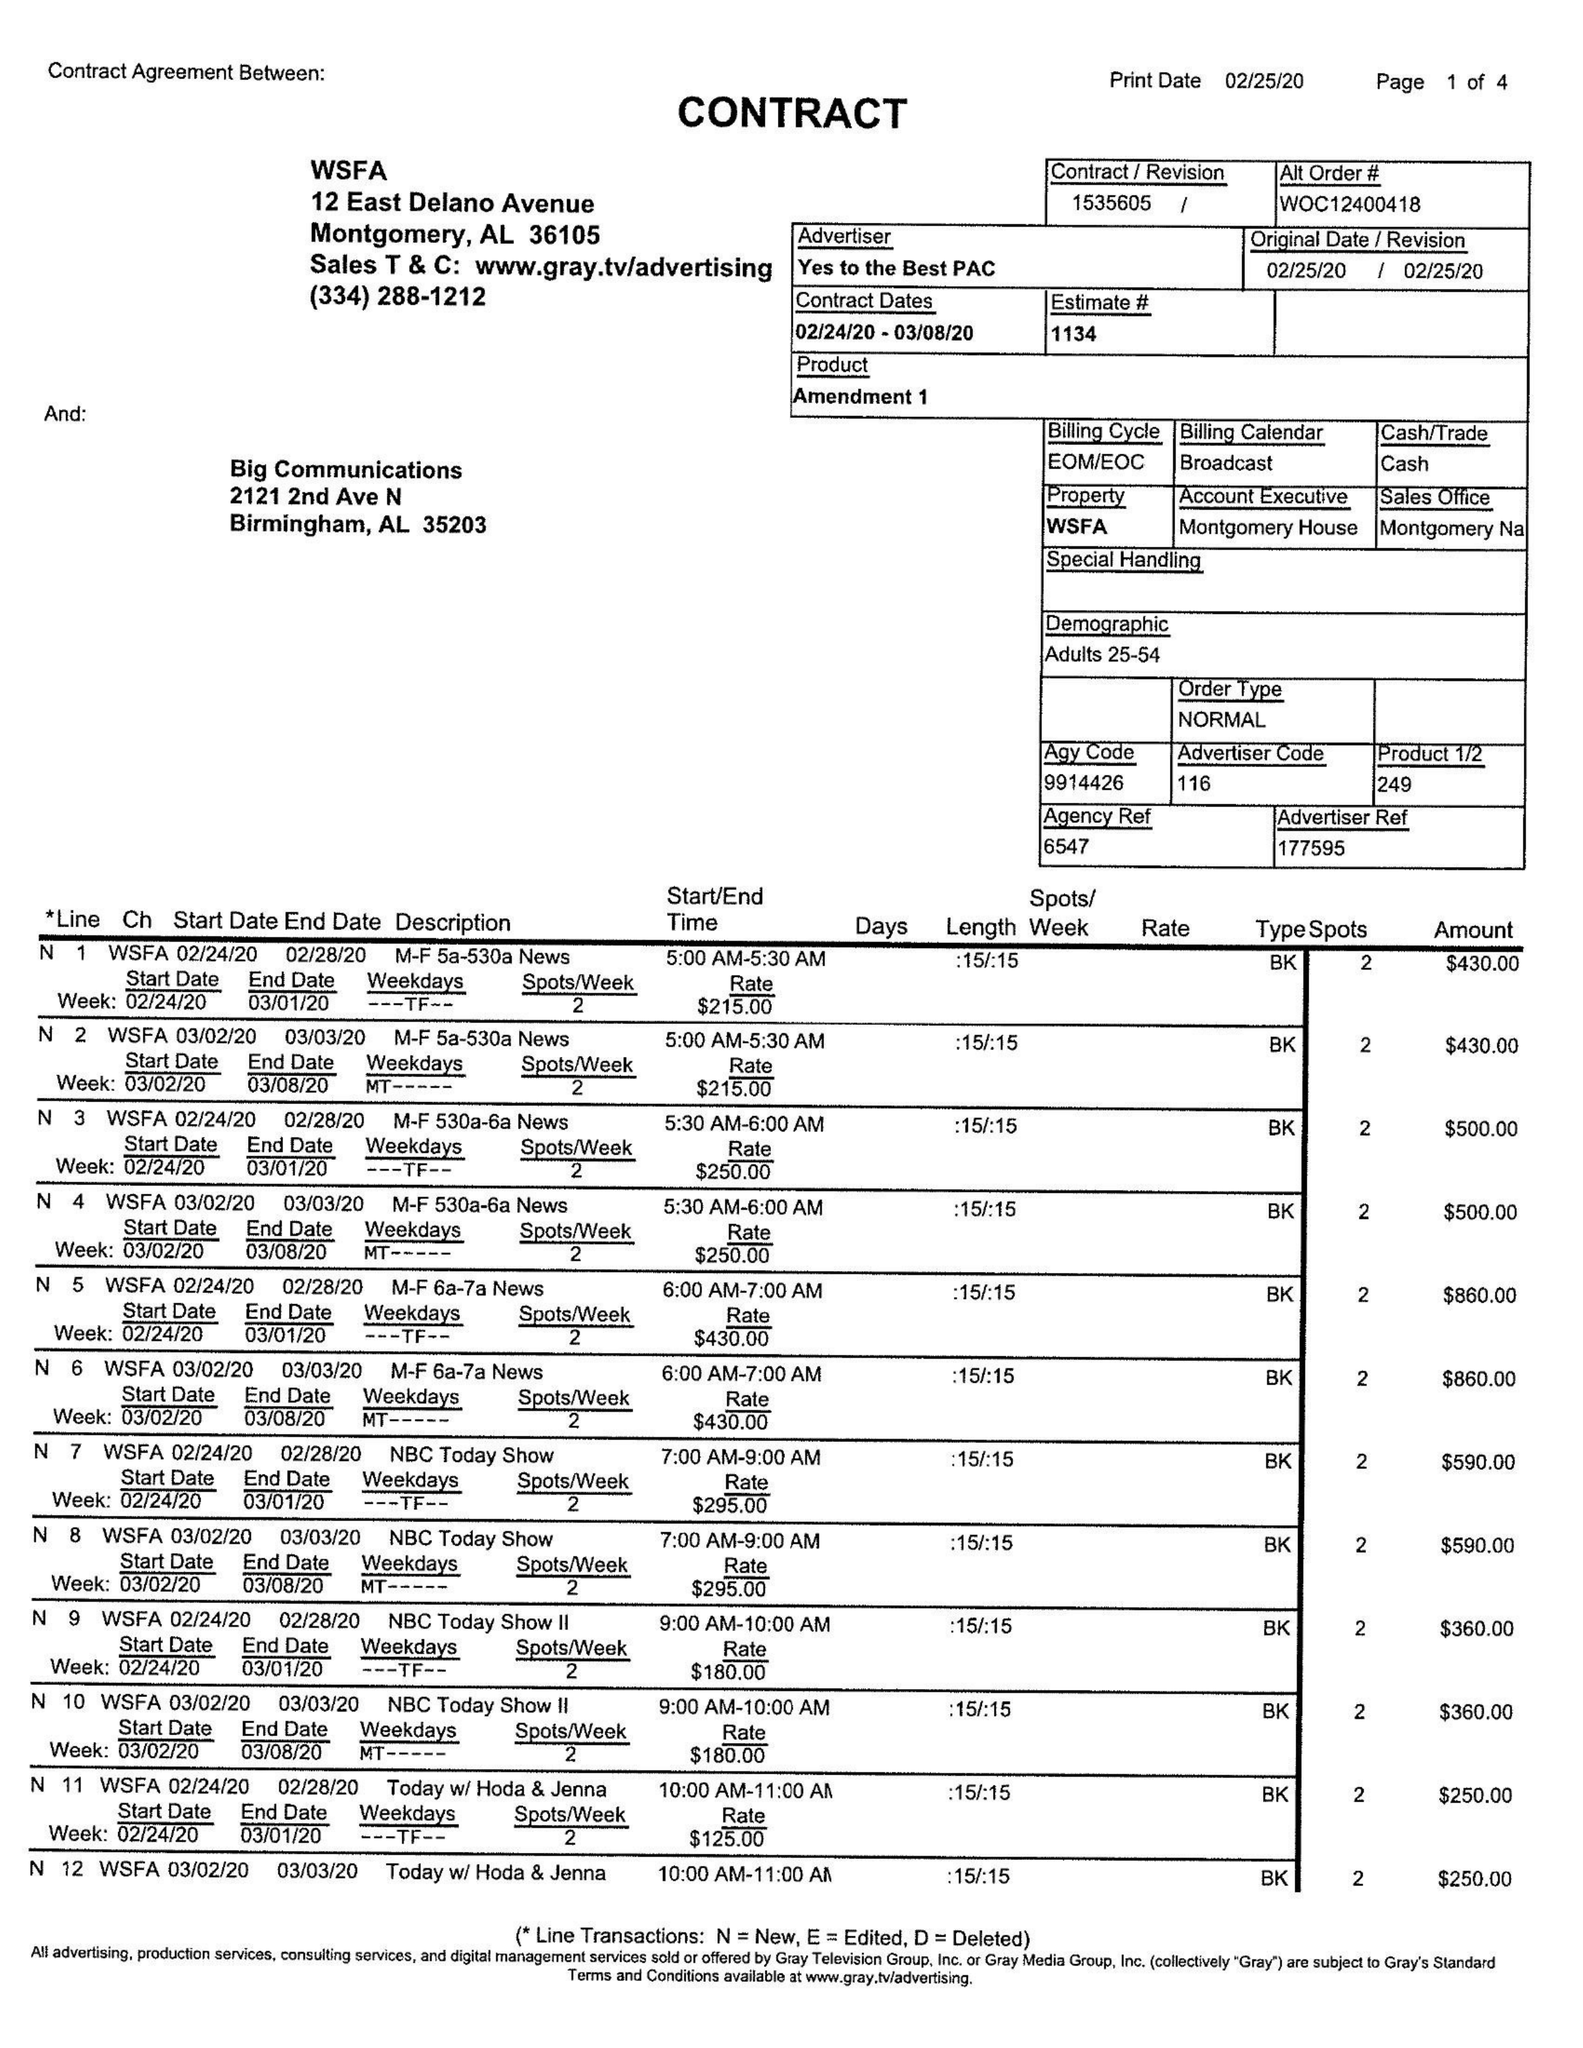What is the value for the flight_to?
Answer the question using a single word or phrase. 03/08/20 